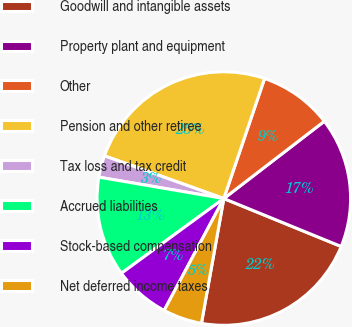Convert chart. <chart><loc_0><loc_0><loc_500><loc_500><pie_chart><fcel>Goodwill and intangible assets<fcel>Property plant and equipment<fcel>Other<fcel>Pension and other retiree<fcel>Tax loss and tax credit<fcel>Accrued liabilities<fcel>Stock-based compensation<fcel>Net deferred income taxes<nl><fcel>21.65%<fcel>16.6%<fcel>9.36%<fcel>24.74%<fcel>2.77%<fcel>12.73%<fcel>7.17%<fcel>4.97%<nl></chart> 